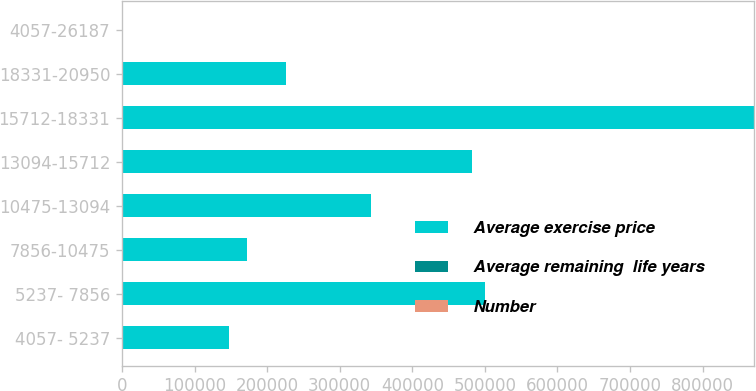Convert chart to OTSL. <chart><loc_0><loc_0><loc_500><loc_500><stacked_bar_chart><ecel><fcel>4057- 5237<fcel>5237- 7856<fcel>7856-10475<fcel>10475-13094<fcel>13094-15712<fcel>15712-18331<fcel>18331-20950<fcel>4057-26187<nl><fcel>Average exercise price<fcel>147840<fcel>500259<fcel>172777<fcel>342805<fcel>481652<fcel>870883<fcel>225450<fcel>117.51<nl><fcel>Average remaining  life years<fcel>47.38<fcel>61.18<fcel>93.83<fcel>117.51<fcel>139.21<fcel>169.61<fcel>187.64<fcel>140.68<nl><fcel>Number<fcel>1.7<fcel>1.2<fcel>4.1<fcel>5.2<fcel>6.4<fcel>7.8<fcel>8.7<fcel>6.1<nl></chart> 